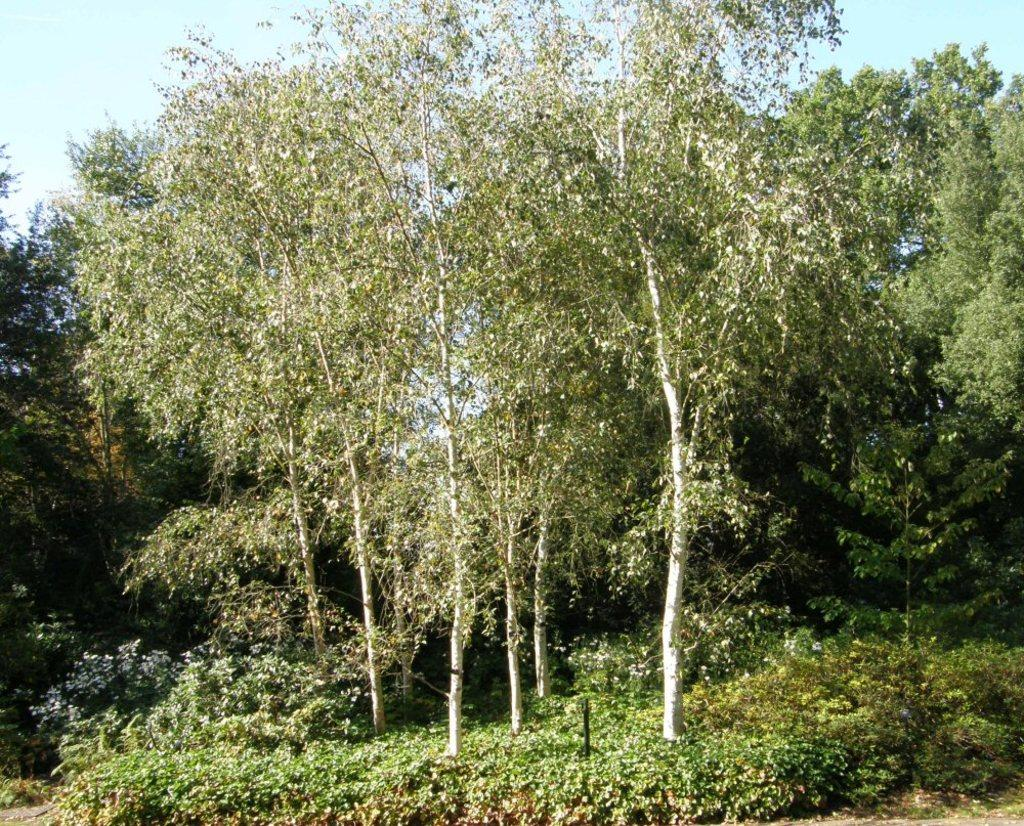What type of vegetation can be seen in the image? There are trees and plants in the image. Where are the plants located in the image? The plants are in the middle of the image. What can be seen in the background of the image? The sky is visible in the background of the image. What type of lace can be seen on the secretary's clothing in the image? There is no secretary or lace present in the image; it features trees and plants. Can you compare the size of the plants to the secretary's desk in the image? There is no secretary or desk present in the image, so a comparison cannot be made. 